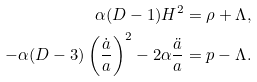<formula> <loc_0><loc_0><loc_500><loc_500>\alpha ( D - 1 ) H ^ { 2 } & = \rho + \Lambda , \\ - \alpha ( D - 3 ) \left ( \frac { \dot { a } } { a } \right ) ^ { 2 } - 2 \alpha \frac { \ddot { a } } { a } & = p - \Lambda .</formula> 